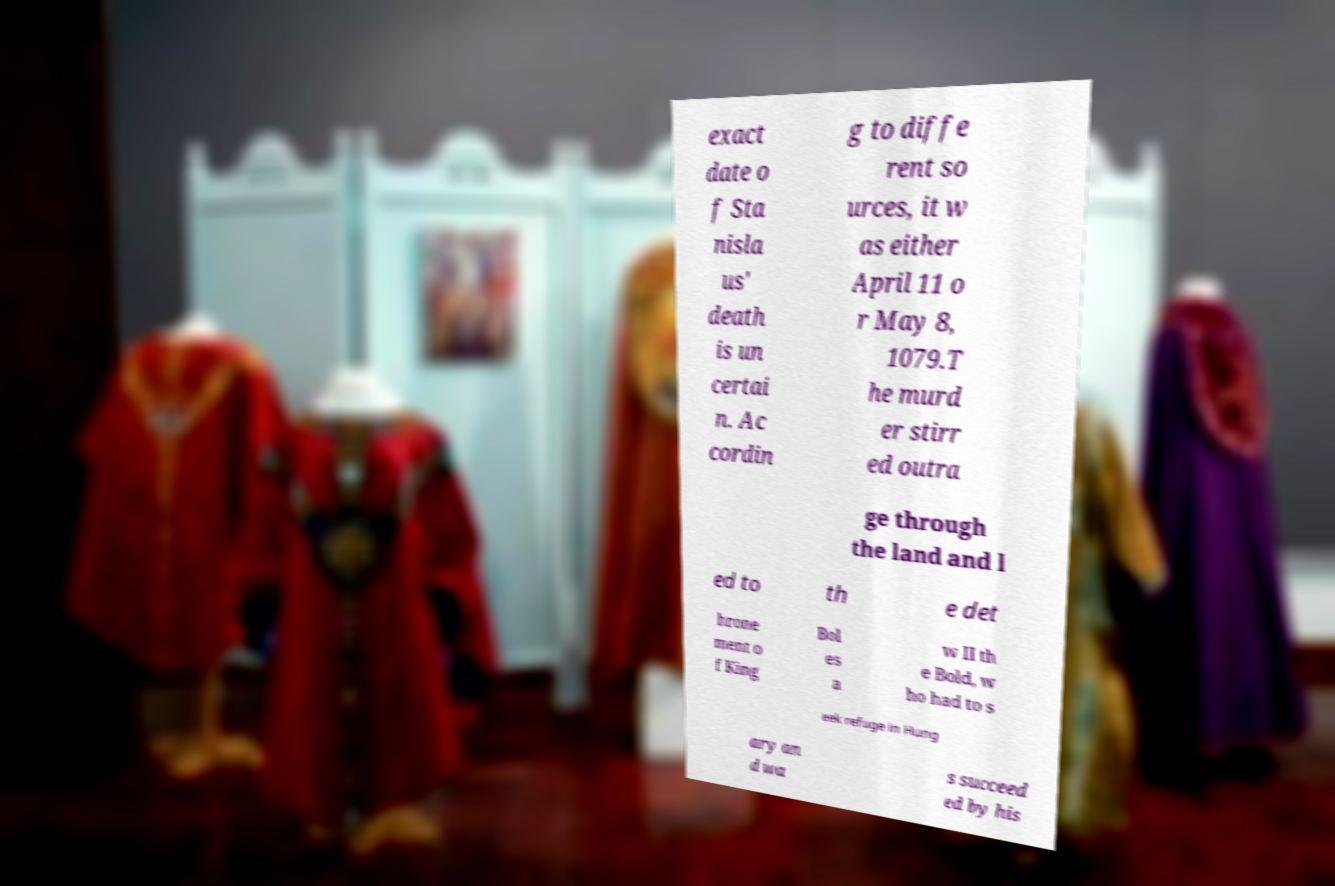For documentation purposes, I need the text within this image transcribed. Could you provide that? exact date o f Sta nisla us' death is un certai n. Ac cordin g to diffe rent so urces, it w as either April 11 o r May 8, 1079.T he murd er stirr ed outra ge through the land and l ed to th e det hrone ment o f King Bol es a w II th e Bold, w ho had to s eek refuge in Hung ary an d wa s succeed ed by his 